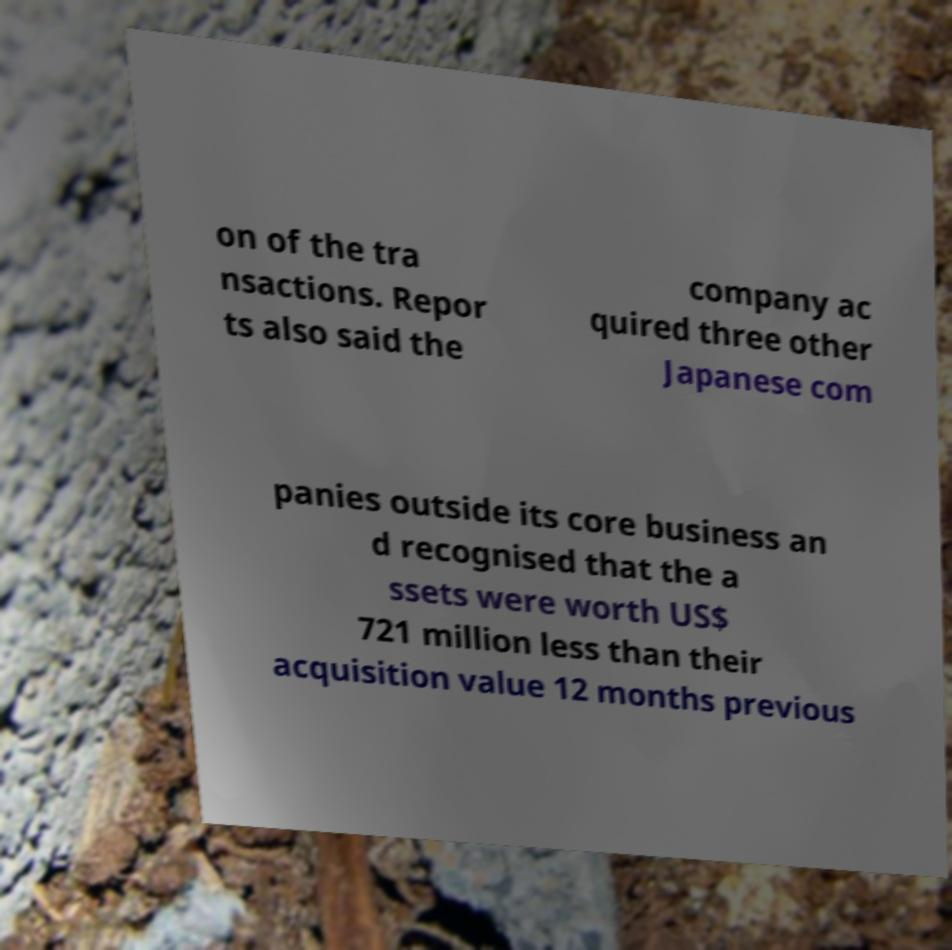What messages or text are displayed in this image? I need them in a readable, typed format. on of the tra nsactions. Repor ts also said the company ac quired three other Japanese com panies outside its core business an d recognised that the a ssets were worth US$ 721 million less than their acquisition value 12 months previous 